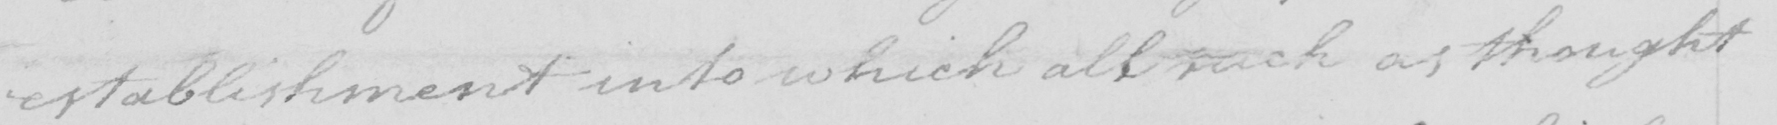What is written in this line of handwriting? establishment into which all such as thought 